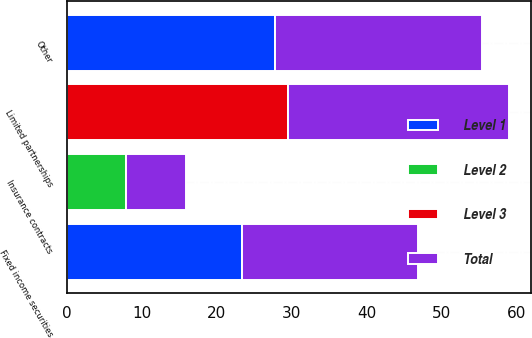Convert chart. <chart><loc_0><loc_0><loc_500><loc_500><stacked_bar_chart><ecel><fcel>Limited partnerships<fcel>Fixed income securities<fcel>Insurance contracts<fcel>Other<nl><fcel>Level 1<fcel>0<fcel>23.4<fcel>0<fcel>27.7<nl><fcel>Level 2<fcel>0<fcel>0<fcel>7.9<fcel>0<nl><fcel>Level 3<fcel>29.5<fcel>0<fcel>0<fcel>0<nl><fcel>Total<fcel>29.5<fcel>23.4<fcel>7.9<fcel>27.7<nl></chart> 